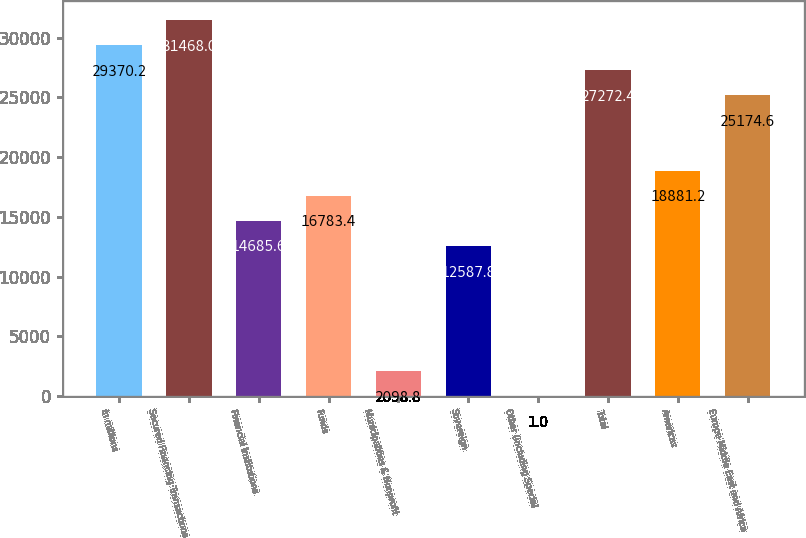Convert chart to OTSL. <chart><loc_0><loc_0><loc_500><loc_500><bar_chart><fcel>in millions<fcel>Secured Financing Transactions<fcel>Financial Institutions<fcel>Funds<fcel>Municipalities & Nonprofit<fcel>Sovereign<fcel>Other (including Special<fcel>Total<fcel>Americas<fcel>Europe Middle East and Africa<nl><fcel>29370.2<fcel>31468<fcel>14685.6<fcel>16783.4<fcel>2098.8<fcel>12587.8<fcel>1<fcel>27272.4<fcel>18881.2<fcel>25174.6<nl></chart> 